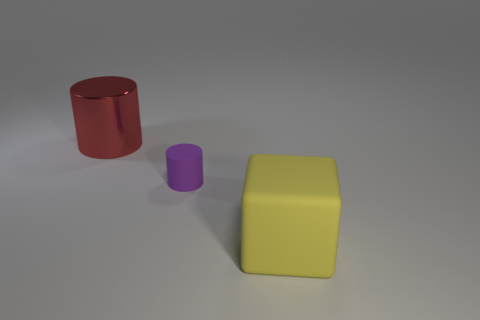How many metallic cylinders have the same color as the tiny matte thing?
Offer a very short reply. 0. Is the number of purple cylinders that are behind the large yellow cube less than the number of things that are in front of the tiny object?
Ensure brevity in your answer.  No. Are there any red shiny things in front of the small object?
Your answer should be very brief. No. There is a large thing to the left of the big thing that is in front of the metal cylinder; are there any red cylinders that are on the right side of it?
Give a very brief answer. No. There is a large object that is behind the purple rubber object; is its shape the same as the yellow rubber thing?
Make the answer very short. No. The other small object that is the same material as the yellow thing is what color?
Offer a terse response. Purple. How many red cylinders are made of the same material as the big red thing?
Provide a short and direct response. 0. There is a cylinder in front of the object that is to the left of the cylinder that is on the right side of the big red thing; what is its color?
Ensure brevity in your answer.  Purple. Is the shiny object the same size as the cube?
Provide a short and direct response. Yes. Are there any other things that are the same shape as the purple object?
Give a very brief answer. Yes. 